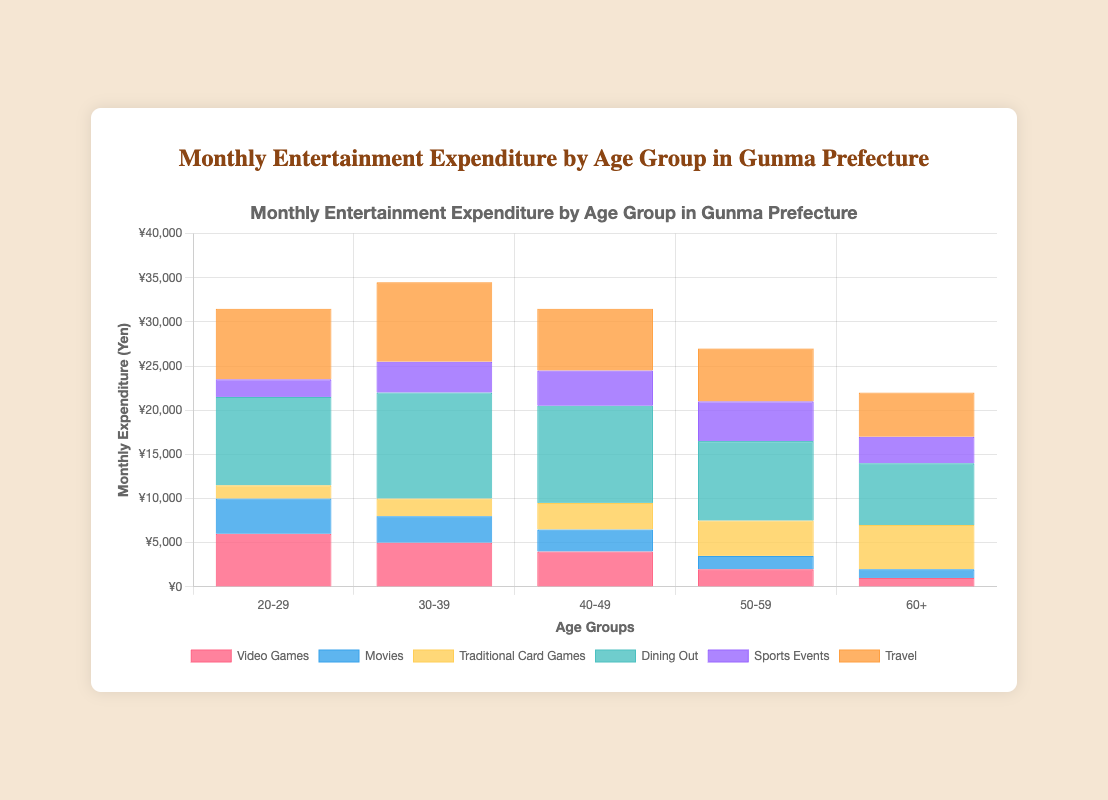What is the total monthly expenditure on entertainment for the age group 20-29? Add up all expenditures for the age group 20-29: Video Games (6000) + Movies (4000) + Traditional Card Games (1500) + Dining Out (10000) + Sports Events (2000) + Travel (8000) = 31500
Answer: 31500 Which age group spends the most on Dining Out each month? Compare the expenditures on Dining Out across all age groups: 20-29 (10000), 30-39 (12000), 40-49 (11000), 50-59 (9000), 60+ (7000). The highest expenditure is 12000 for the age group 30-39
Answer: 30-39 How does the expenditure on Traditional Card Games change across the different age groups? Examine the expenditure on Traditional Card Games for each age group: 20-29 (1500), 30-39 (2000), 40-49 (3000), 50-59 (4000), 60+ (5000). It increases steadily with age
Answer: Increases with age For the age group 60+, which entertainment type has the highest expenditure? Compare each expenditure for the age group 60+: Video Games (1000), Movies (1000), Traditional Card Games (5000), Dining Out (7000), Sports Events (3000), Travel (5000). Dining Out has the highest expenditure
Answer: Dining Out What is the average monthly expenditure on Travel across all age groups? Add up the expenditure on Travel for all age groups and divide by the number of age groups: (8000 + 9000 + 7000 + 6000 + 5000) / 5 = 35000 / 5 = 7000
Answer: 7000 How does the expenditure on Video Games compare between the age groups 20-29 and 60+? Compare the given expenditures: 20-29 (6000) and 60+ (1000). The age group 20-29 spends 6000 - 1000 = 5000 yen more than the age group 60+
Answer: 5000 yen more for 20-29 What is the total monthly expenditure for all age groups combined on Movies? Add the expenditure on Movies for all age groups: 20-29 (4000) + 30-39 (3000) + 40-49 (2500) + 50-59 (1500) + 60+ (1000) = 12000
Answer: 12000 Which age group spends the least overall on entertainment? Add up the total expenditures for each age group and compare: 20-29 (31500), 30-39 (34500), 40-49 (31500), 50-59 (27000), 60+ (22000). The age group 60+ has the lowest total expenditure (22000)
Answer: 60+ How does the expenditure on Sports Events differ between the age groups 30-39 and 50-59? Compare the expenditures: 30-39 (3500) and 50-59 (4500). The age group 50-59 spends 4500 - 3500 = 1000 yen more than the age group 30-39
Answer: 1000 yen more for 50-59 Which entertainment type saw the highest expenditure in the 40-49 age group? Compare each expenditure for the age group 40-49: Video Games (4000), Movies (2500), Traditional Card Games (3000), Dining Out (11000), Sports Events (4000), Travel (7000). Dining Out has the highest expenditure
Answer: Dining Out 